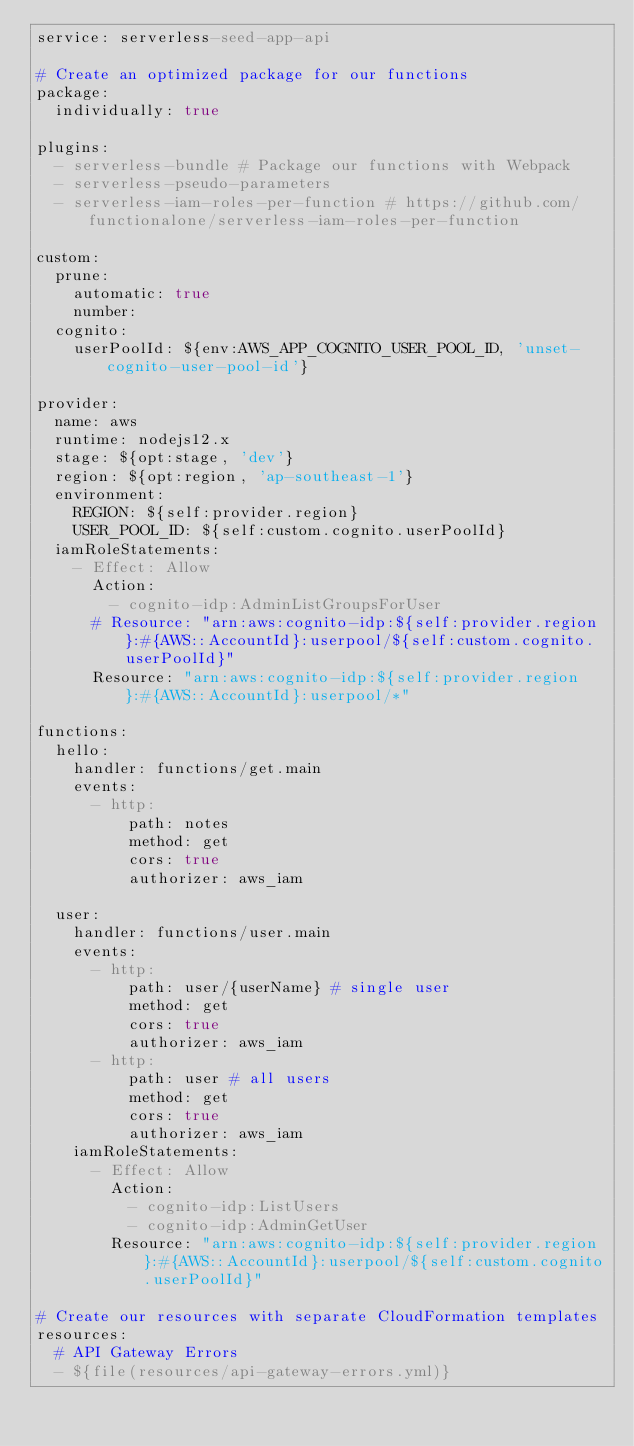<code> <loc_0><loc_0><loc_500><loc_500><_YAML_>service: serverless-seed-app-api

# Create an optimized package for our functions
package:
  individually: true

plugins:
  - serverless-bundle # Package our functions with Webpack
  - serverless-pseudo-parameters
  - serverless-iam-roles-per-function # https://github.com/functionalone/serverless-iam-roles-per-function

custom:
  prune:
    automatic: true
    number:
  cognito:
    userPoolId: ${env:AWS_APP_COGNITO_USER_POOL_ID, 'unset-cognito-user-pool-id'}

provider:
  name: aws
  runtime: nodejs12.x
  stage: ${opt:stage, 'dev'}
  region: ${opt:region, 'ap-southeast-1'}
  environment:
    REGION: ${self:provider.region}
    USER_POOL_ID: ${self:custom.cognito.userPoolId}
  iamRoleStatements:
    - Effect: Allow
      Action:
        - cognito-idp:AdminListGroupsForUser
      # Resource: "arn:aws:cognito-idp:${self:provider.region}:#{AWS::AccountId}:userpool/${self:custom.cognito.userPoolId}"
      Resource: "arn:aws:cognito-idp:${self:provider.region}:#{AWS::AccountId}:userpool/*"

functions:
  hello:
    handler: functions/get.main
    events:
      - http:
          path: notes
          method: get
          cors: true
          authorizer: aws_iam

  user:
    handler: functions/user.main
    events:
      - http:
          path: user/{userName} # single user
          method: get
          cors: true
          authorizer: aws_iam
      - http:
          path: user # all users
          method: get
          cors: true
          authorizer: aws_iam
    iamRoleStatements:
      - Effect: Allow
        Action:
          - cognito-idp:ListUsers
          - cognito-idp:AdminGetUser
        Resource: "arn:aws:cognito-idp:${self:provider.region}:#{AWS::AccountId}:userpool/${self:custom.cognito.userPoolId}"

# Create our resources with separate CloudFormation templates
resources:
  # API Gateway Errors
  - ${file(resources/api-gateway-errors.yml)}
</code> 